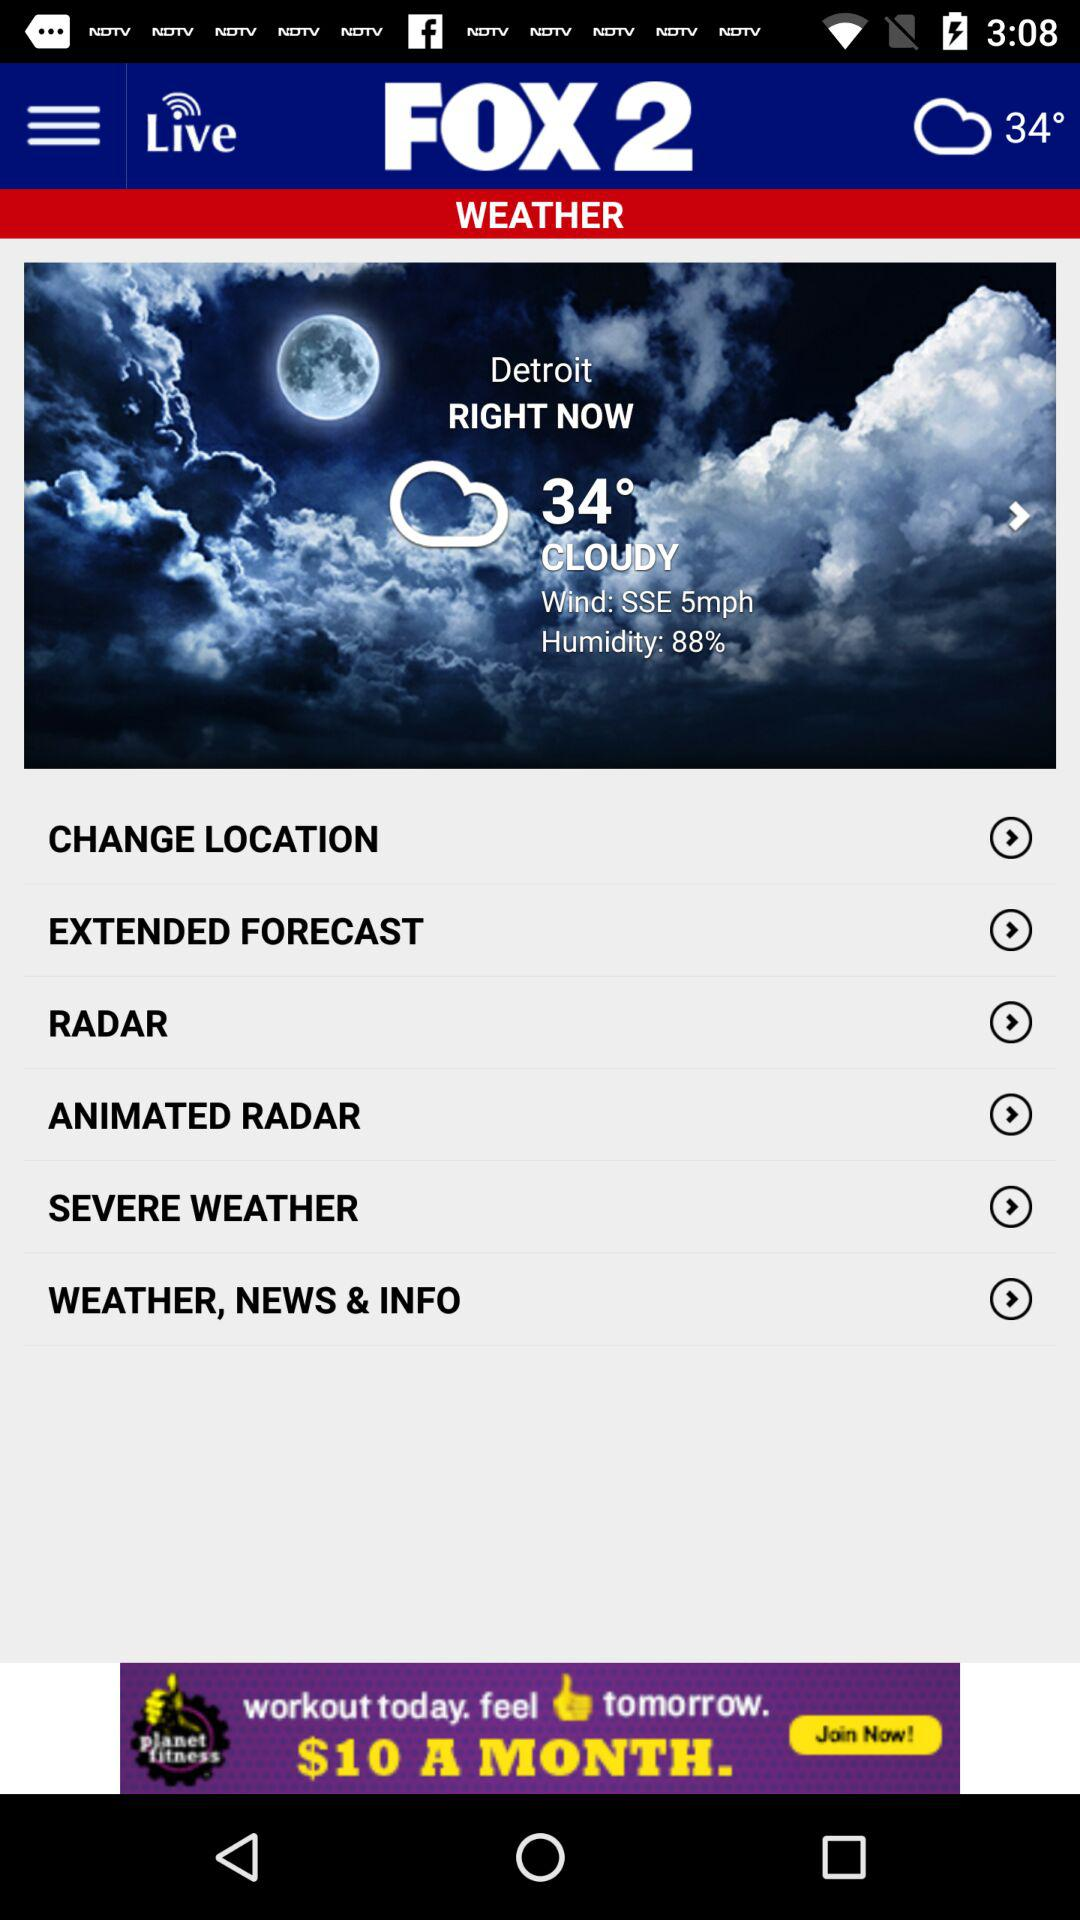How many degrees Fahrenheit is the temperature in Detroit? 34° 